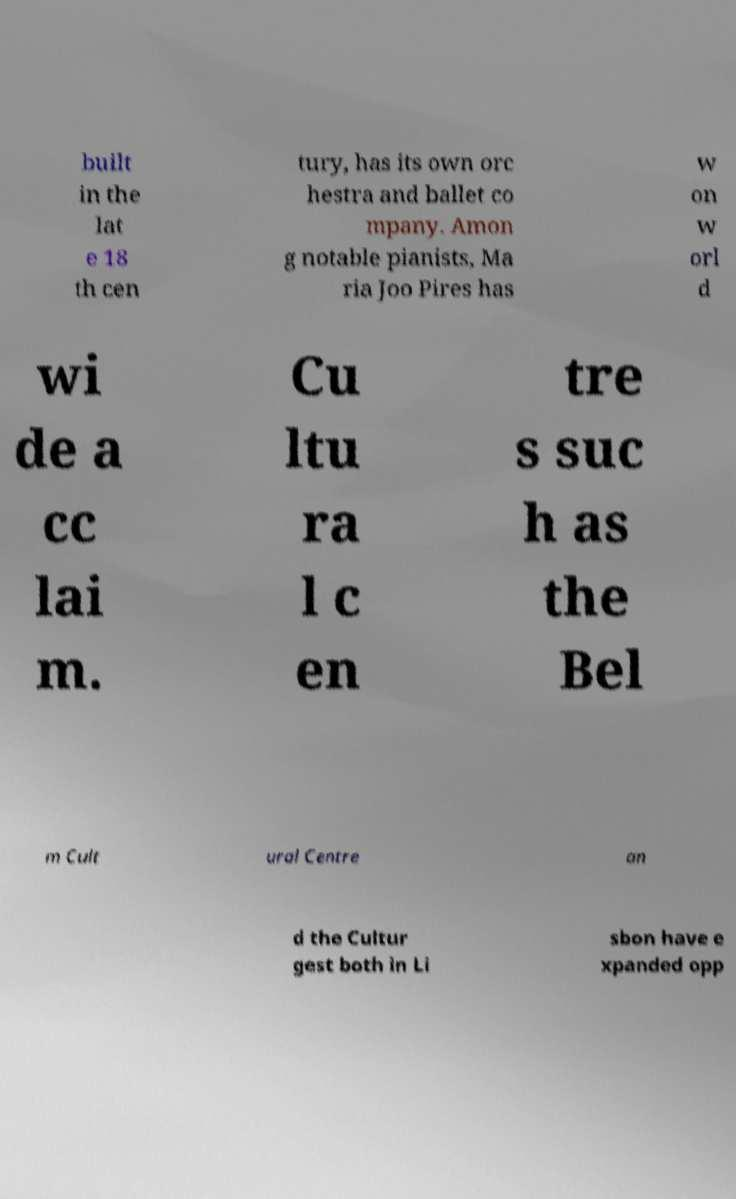Can you read and provide the text displayed in the image?This photo seems to have some interesting text. Can you extract and type it out for me? built in the lat e 18 th cen tury, has its own orc hestra and ballet co mpany. Amon g notable pianists, Ma ria Joo Pires has w on w orl d wi de a cc lai m. Cu ltu ra l c en tre s suc h as the Bel m Cult ural Centre an d the Cultur gest both in Li sbon have e xpanded opp 